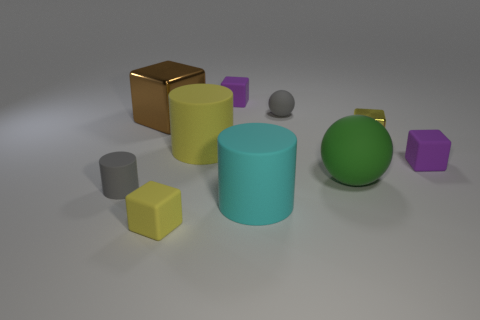What shape is the yellow object that is both behind the big matte ball and left of the small metal object?
Ensure brevity in your answer.  Cylinder. Is there a big yellow matte object that has the same shape as the large cyan thing?
Your answer should be compact. Yes. There is a green object that is the same size as the yellow cylinder; what shape is it?
Offer a very short reply. Sphere. What material is the large green thing?
Your answer should be compact. Rubber. There is a gray matte thing to the left of the large object that is left of the big cylinder behind the big rubber sphere; how big is it?
Your answer should be compact. Small. What is the material of the cylinder that is the same color as the tiny ball?
Provide a short and direct response. Rubber. What number of shiny things are either tiny blocks or large green things?
Your answer should be compact. 1. The cyan cylinder is what size?
Your response must be concise. Large. How many things are either tiny yellow metal spheres or matte objects that are behind the green rubber sphere?
Offer a very short reply. 4. What number of other things are there of the same color as the large metal block?
Provide a succinct answer. 0. 